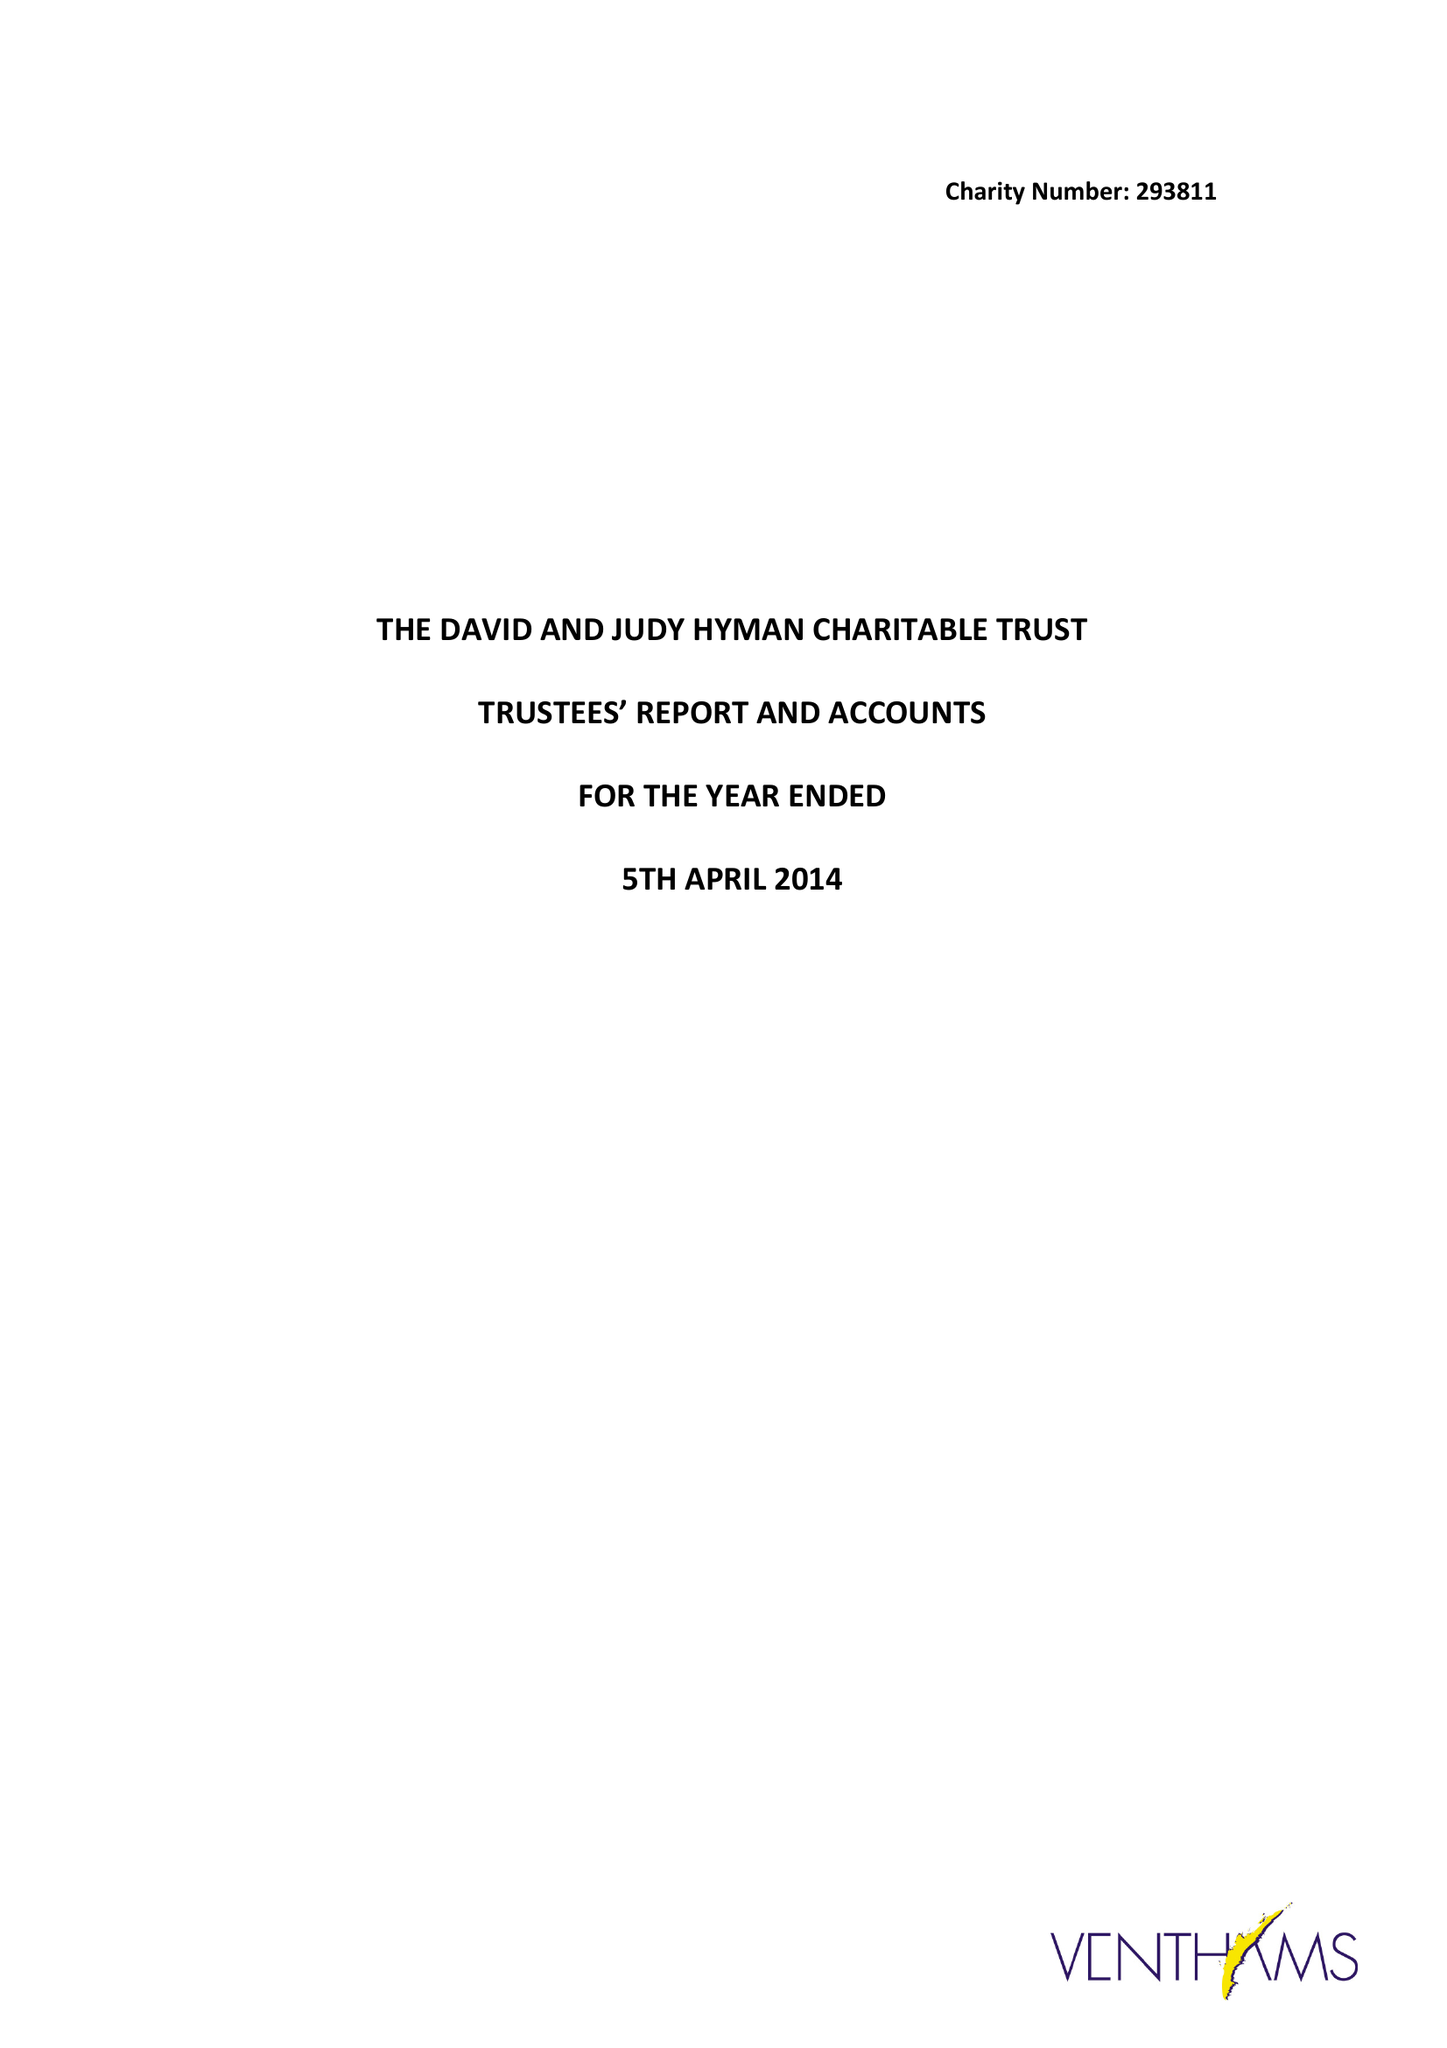What is the value for the spending_annually_in_british_pounds?
Answer the question using a single word or phrase. 11636.00 